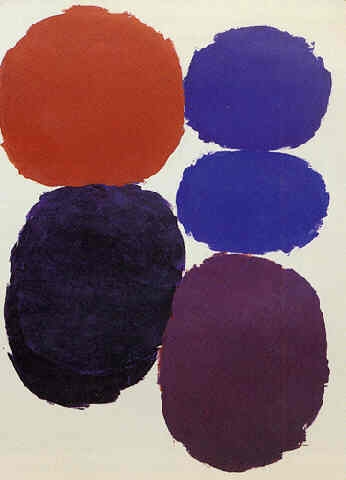Analyze the image in a comprehensive and detailed manner.
 The image presents an abstract art piece that captures the viewer's attention with its simplicity and use of color. Dominating the composition are five circles, each varying in size and color, arranged vertically. The largest circle, painted in a vibrant shade of red, anchors the piece at the bottom. As our eyes move upwards, we encounter circles in blue, dark blue, purple, and finally, a small orange circle at the top. The minimalistic style of the artwork, with its clean lines and lack of extraneous detail, allows the colors and shapes to take center stage. This is a classic example of abstract art, where the focus is not on a realistic depiction of objects but rather on the interplay of color, shape, and space. 